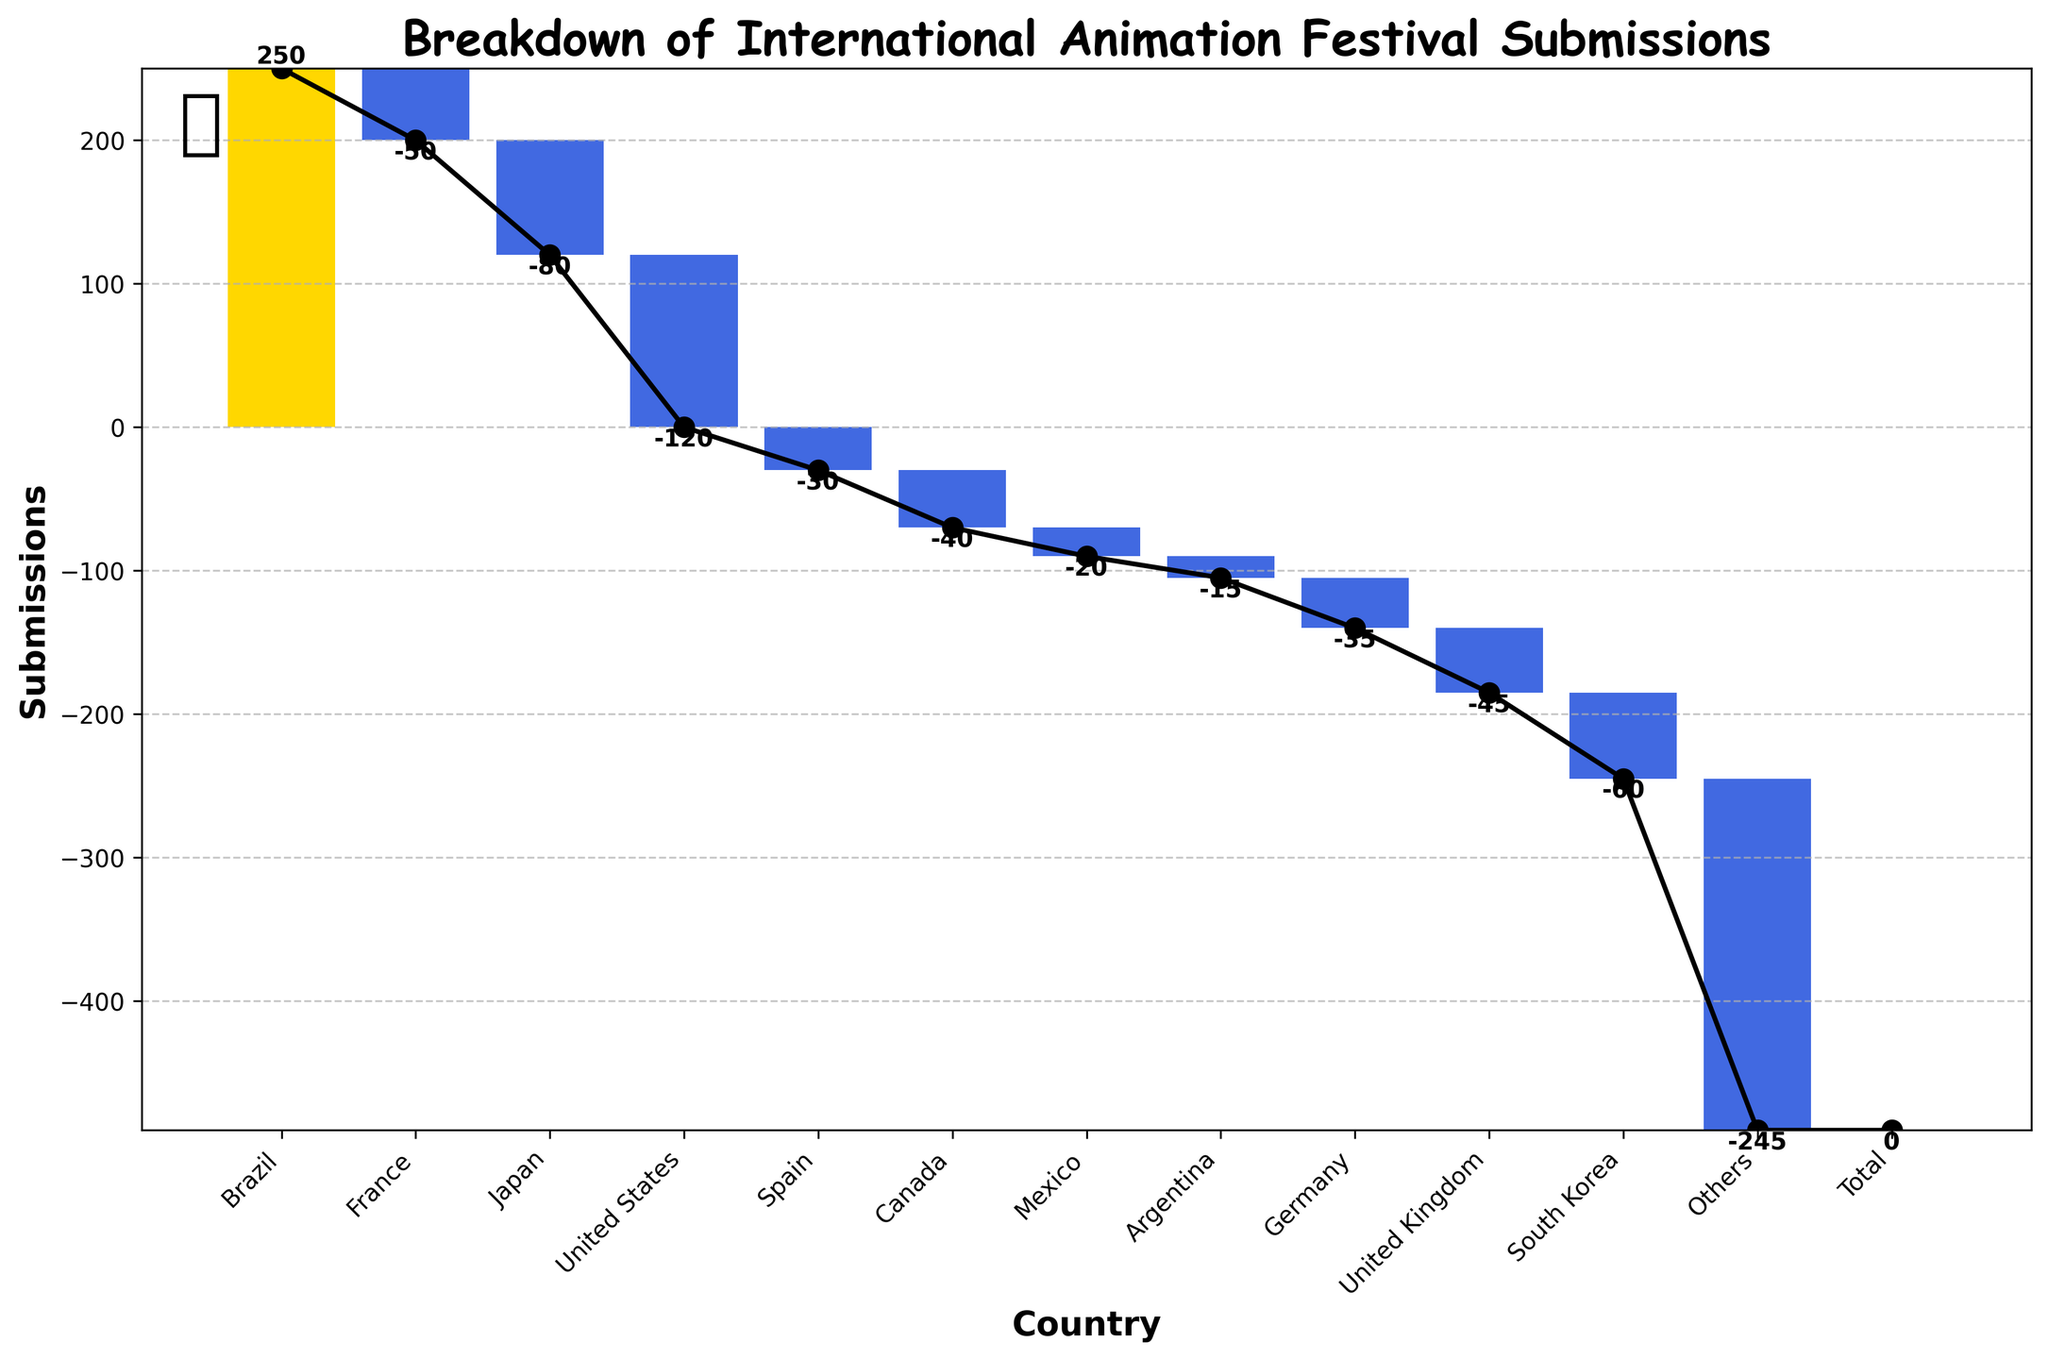What is the title of the chart? The title of the chart is located at the top of the figure and provides a summary of what the chart is about. By reading the title, we can understand that the chart focuses on the submissions breakdown by country for an international animation festival.
Answer: Breakdown of International Animation Festival Submissions How many countries have negative submissions? Count the number of countries whose bars are colored in blue, indicating negative submissions.
Answer: 11 What is the net submission for Brazil? Look at the bar corresponding to Brazil on the far left; since it is highlighted and has a positive value, read the figure given next to Brazil's bar.
Answer: 250 Which country has the largest negative submission? Find the bar with the deepest blue color and the highest negative number next to it, and identify the corresponding country.
Answer: United States What is the cumulative value of submissions after the 5th country? Add up the submissions values sequentially up to the 5th country that includes Brazil, France, Japan, United States, and Spain. Then, verify the cumulative value at the line segment after these countries on the chart.
Answer: -30 By how much is France's submission less than Brazil's? Subtract France's submission value (-50) from Brazil's submission value (250) to get the difference.
Answer: 300 Which countries contribute to the positive submission? Note all countries whose bars are colored in gold, indicating positive submissions.
Answer: Brazil How does the submission from the United States compare to that from Japan? Compare the submission values from both countries by referring to the negative values next to their bars; find which value is more negative or less negative.
Answer: The United States has a larger negative submission than Japan (-120 vs. -80) What is the cumulative total submission at the 9th country? Count the countries along the x-axis to the 9th country, which are Brazil, France, Japan, United States, Spain, Canada, Mexico, Argentina, and Germany. Look at the cumulative value line after Germany, and note the value.
Answer: -210 What is the overall trend in submission values as you move from left to right on the chart? Observe the cumulative line plot from left (starting with Brazil) to right (ending with Others). Note the general direction (increasing, steady, or decreasing).
Answer: Decreasing 